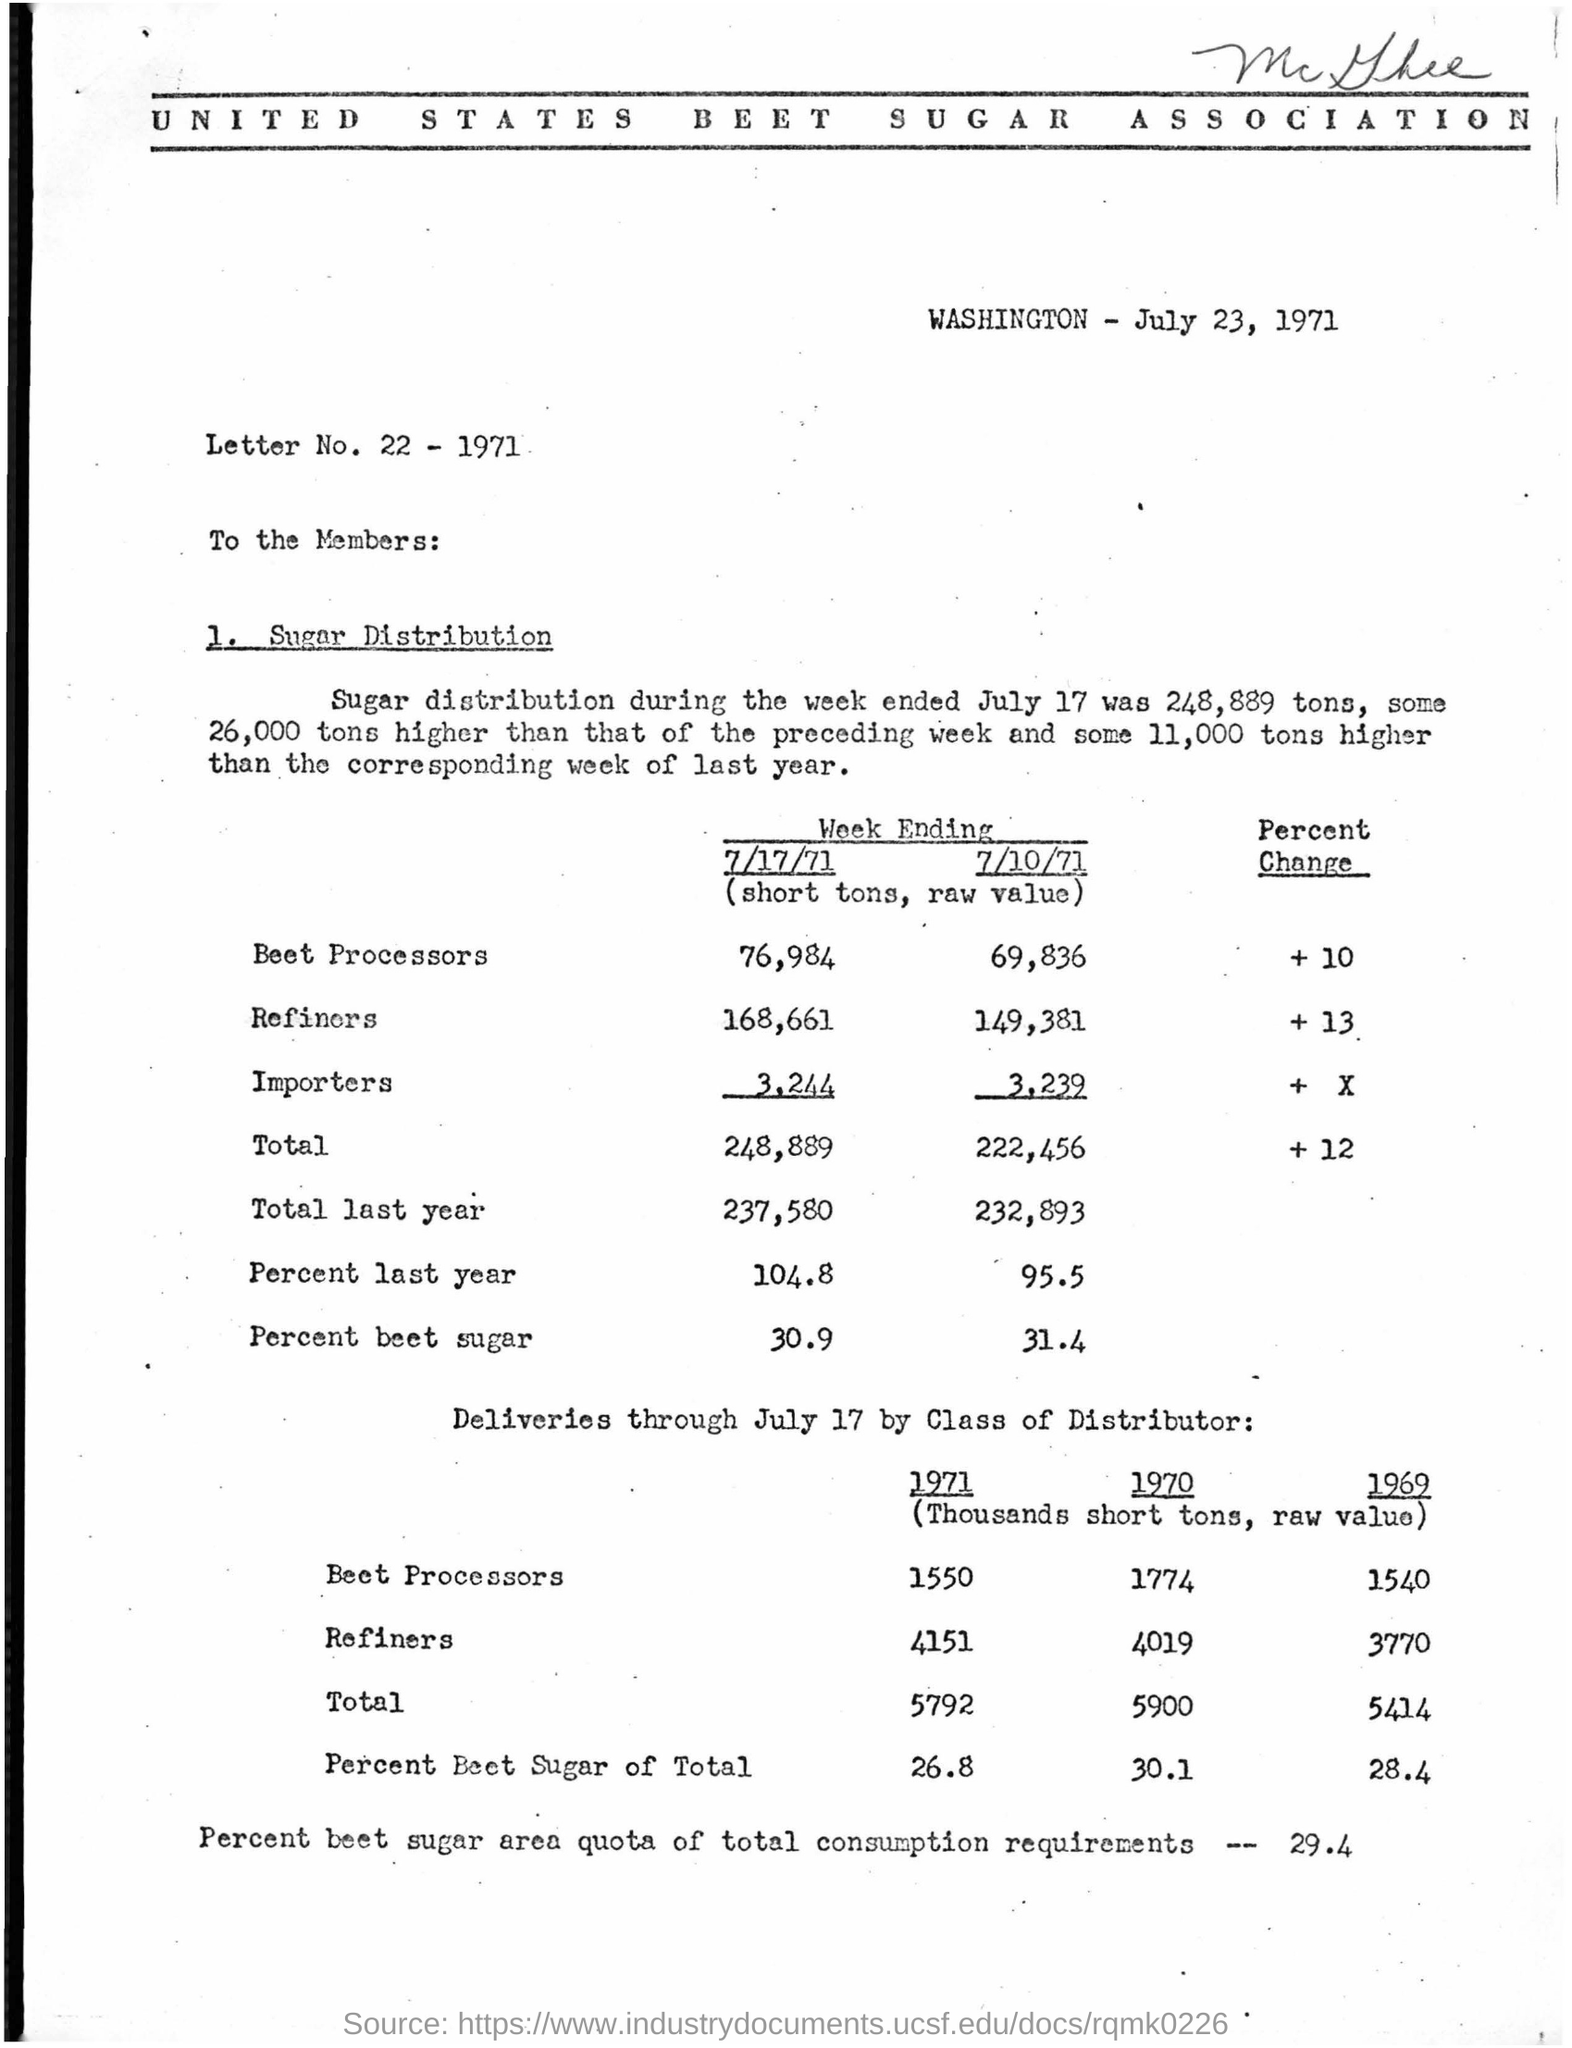What is the date of this document?
Offer a terse response. July 23, 1971. To whom the letter addressed to?
Offer a very short reply. To the Members. Where is the place the letter prepared?
Your answer should be very brief. Washington. 